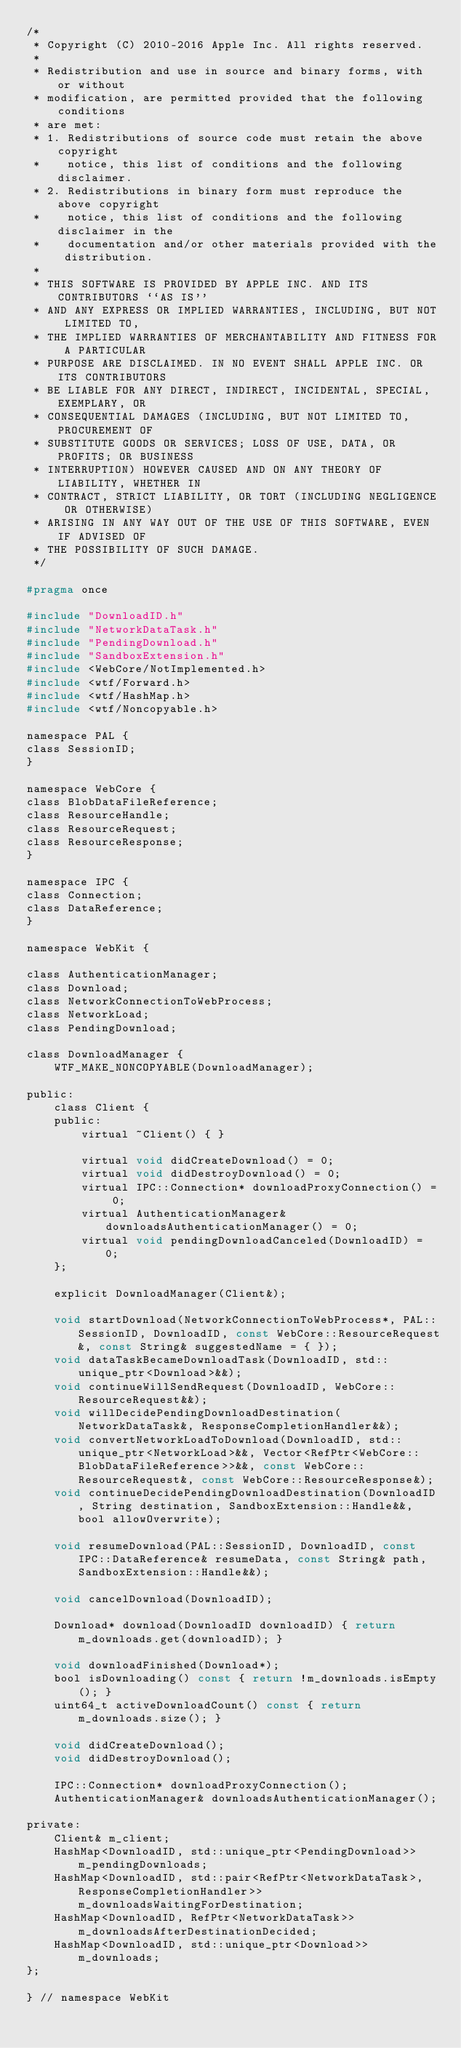<code> <loc_0><loc_0><loc_500><loc_500><_C_>/*
 * Copyright (C) 2010-2016 Apple Inc. All rights reserved.
 *
 * Redistribution and use in source and binary forms, with or without
 * modification, are permitted provided that the following conditions
 * are met:
 * 1. Redistributions of source code must retain the above copyright
 *    notice, this list of conditions and the following disclaimer.
 * 2. Redistributions in binary form must reproduce the above copyright
 *    notice, this list of conditions and the following disclaimer in the
 *    documentation and/or other materials provided with the distribution.
 *
 * THIS SOFTWARE IS PROVIDED BY APPLE INC. AND ITS CONTRIBUTORS ``AS IS''
 * AND ANY EXPRESS OR IMPLIED WARRANTIES, INCLUDING, BUT NOT LIMITED TO,
 * THE IMPLIED WARRANTIES OF MERCHANTABILITY AND FITNESS FOR A PARTICULAR
 * PURPOSE ARE DISCLAIMED. IN NO EVENT SHALL APPLE INC. OR ITS CONTRIBUTORS
 * BE LIABLE FOR ANY DIRECT, INDIRECT, INCIDENTAL, SPECIAL, EXEMPLARY, OR
 * CONSEQUENTIAL DAMAGES (INCLUDING, BUT NOT LIMITED TO, PROCUREMENT OF
 * SUBSTITUTE GOODS OR SERVICES; LOSS OF USE, DATA, OR PROFITS; OR BUSINESS
 * INTERRUPTION) HOWEVER CAUSED AND ON ANY THEORY OF LIABILITY, WHETHER IN
 * CONTRACT, STRICT LIABILITY, OR TORT (INCLUDING NEGLIGENCE OR OTHERWISE)
 * ARISING IN ANY WAY OUT OF THE USE OF THIS SOFTWARE, EVEN IF ADVISED OF
 * THE POSSIBILITY OF SUCH DAMAGE.
 */

#pragma once

#include "DownloadID.h"
#include "NetworkDataTask.h"
#include "PendingDownload.h"
#include "SandboxExtension.h"
#include <WebCore/NotImplemented.h>
#include <wtf/Forward.h>
#include <wtf/HashMap.h>
#include <wtf/Noncopyable.h>

namespace PAL {
class SessionID;
}

namespace WebCore {
class BlobDataFileReference;
class ResourceHandle;
class ResourceRequest;
class ResourceResponse;
}

namespace IPC {
class Connection;
class DataReference;
}

namespace WebKit {

class AuthenticationManager;
class Download;
class NetworkConnectionToWebProcess;
class NetworkLoad;
class PendingDownload;

class DownloadManager {
    WTF_MAKE_NONCOPYABLE(DownloadManager);

public:
    class Client {
    public:
        virtual ~Client() { }

        virtual void didCreateDownload() = 0;
        virtual void didDestroyDownload() = 0;
        virtual IPC::Connection* downloadProxyConnection() = 0;
        virtual AuthenticationManager& downloadsAuthenticationManager() = 0;
        virtual void pendingDownloadCanceled(DownloadID) = 0;
    };

    explicit DownloadManager(Client&);

    void startDownload(NetworkConnectionToWebProcess*, PAL::SessionID, DownloadID, const WebCore::ResourceRequest&, const String& suggestedName = { });
    void dataTaskBecameDownloadTask(DownloadID, std::unique_ptr<Download>&&);
    void continueWillSendRequest(DownloadID, WebCore::ResourceRequest&&);
    void willDecidePendingDownloadDestination(NetworkDataTask&, ResponseCompletionHandler&&);
    void convertNetworkLoadToDownload(DownloadID, std::unique_ptr<NetworkLoad>&&, Vector<RefPtr<WebCore::BlobDataFileReference>>&&, const WebCore::ResourceRequest&, const WebCore::ResourceResponse&);
    void continueDecidePendingDownloadDestination(DownloadID, String destination, SandboxExtension::Handle&&, bool allowOverwrite);

    void resumeDownload(PAL::SessionID, DownloadID, const IPC::DataReference& resumeData, const String& path, SandboxExtension::Handle&&);

    void cancelDownload(DownloadID);
    
    Download* download(DownloadID downloadID) { return m_downloads.get(downloadID); }

    void downloadFinished(Download*);
    bool isDownloading() const { return !m_downloads.isEmpty(); }
    uint64_t activeDownloadCount() const { return m_downloads.size(); }

    void didCreateDownload();
    void didDestroyDownload();

    IPC::Connection* downloadProxyConnection();
    AuthenticationManager& downloadsAuthenticationManager();

private:
    Client& m_client;
    HashMap<DownloadID, std::unique_ptr<PendingDownload>> m_pendingDownloads;
    HashMap<DownloadID, std::pair<RefPtr<NetworkDataTask>, ResponseCompletionHandler>> m_downloadsWaitingForDestination;
    HashMap<DownloadID, RefPtr<NetworkDataTask>> m_downloadsAfterDestinationDecided;
    HashMap<DownloadID, std::unique_ptr<Download>> m_downloads;
};

} // namespace WebKit
</code> 